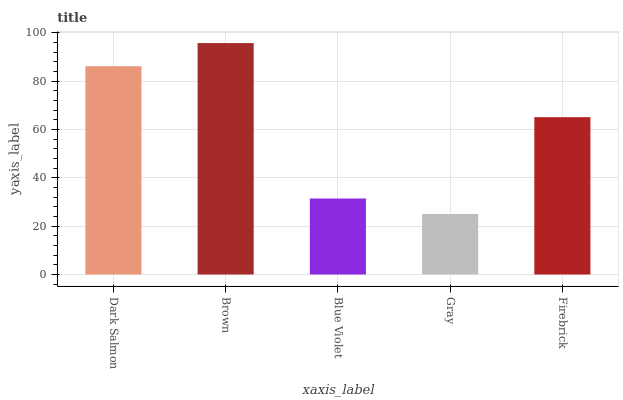Is Gray the minimum?
Answer yes or no. Yes. Is Brown the maximum?
Answer yes or no. Yes. Is Blue Violet the minimum?
Answer yes or no. No. Is Blue Violet the maximum?
Answer yes or no. No. Is Brown greater than Blue Violet?
Answer yes or no. Yes. Is Blue Violet less than Brown?
Answer yes or no. Yes. Is Blue Violet greater than Brown?
Answer yes or no. No. Is Brown less than Blue Violet?
Answer yes or no. No. Is Firebrick the high median?
Answer yes or no. Yes. Is Firebrick the low median?
Answer yes or no. Yes. Is Brown the high median?
Answer yes or no. No. Is Gray the low median?
Answer yes or no. No. 